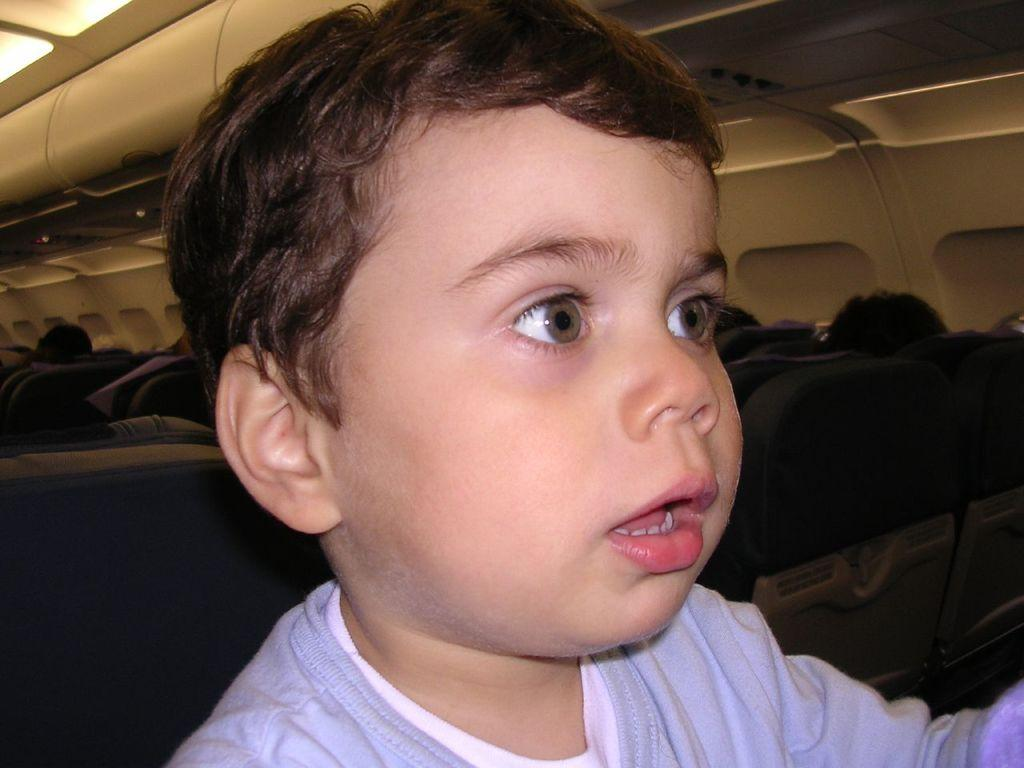What is the main subject of the image? There is a child in the image. Where is the child located? The child is inside a vehicle. What can be seen in the background of the image? There are seats visible in the background of the image. What type of sail can be seen on the child's clothing in the image? There is no sail visible on the child's clothing in the image. Is there a woman accompanying the child in the image? The provided facts do not mention the presence of a woman in the image. 